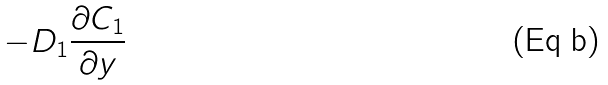Convert formula to latex. <formula><loc_0><loc_0><loc_500><loc_500>- D _ { 1 } \frac { \partial C _ { 1 } } { \partial y }</formula> 